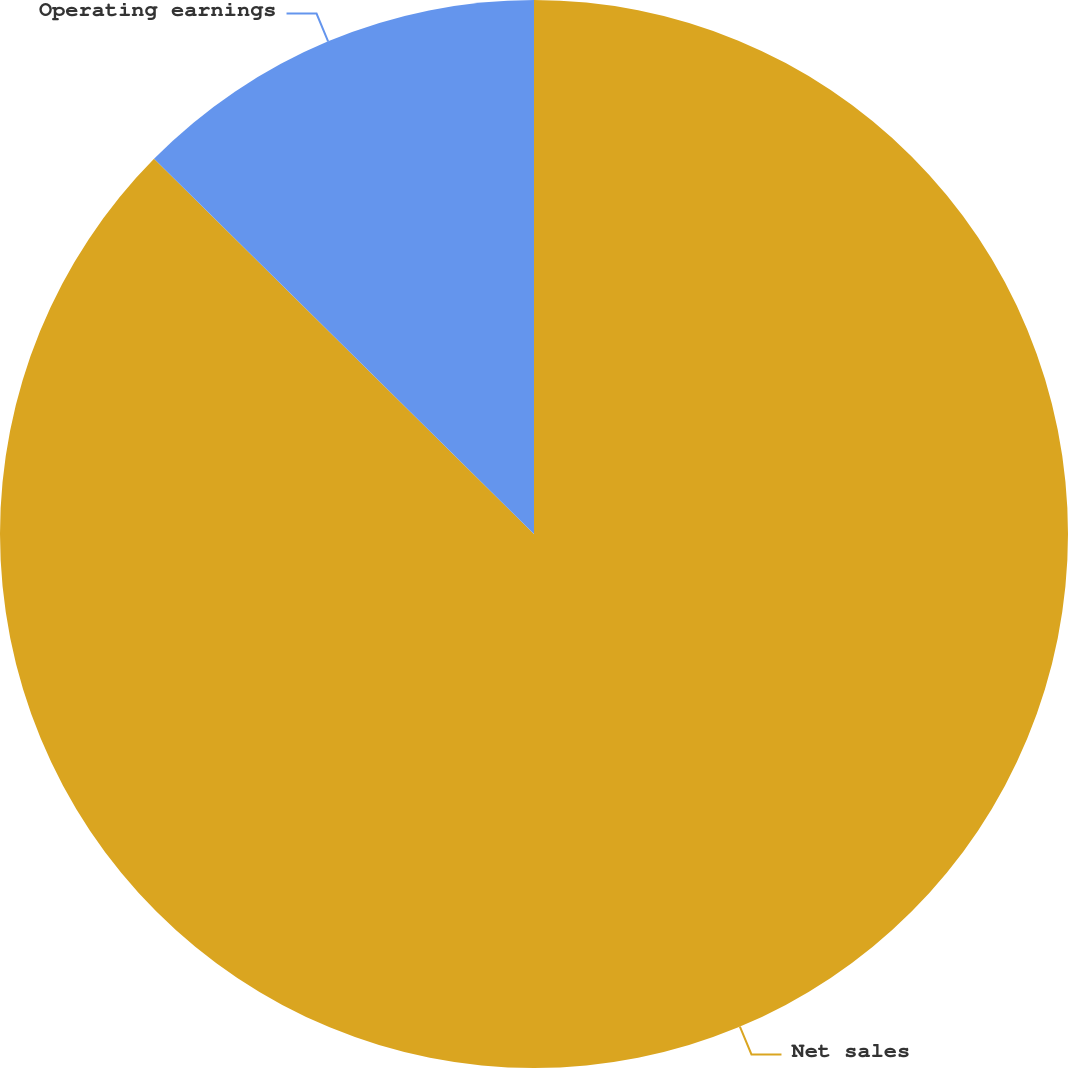<chart> <loc_0><loc_0><loc_500><loc_500><pie_chart><fcel>Net sales<fcel>Operating earnings<nl><fcel>87.4%<fcel>12.6%<nl></chart> 